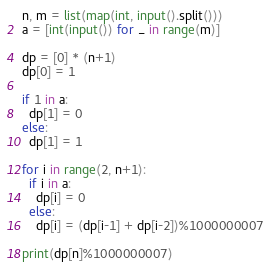<code> <loc_0><loc_0><loc_500><loc_500><_Python_>n, m = list(map(int, input().split()))
a = [int(input()) for _ in range(m)]

dp = [0] * (n+1)
dp[0] = 1

if 1 in a:
  dp[1] = 0
else:
  dp[1] = 1
  
for i in range(2, n+1):
  if i in a:
    dp[i] = 0
  else:
    dp[i] = (dp[i-1] + dp[i-2])%1000000007
  
print(dp[n]%1000000007)
</code> 